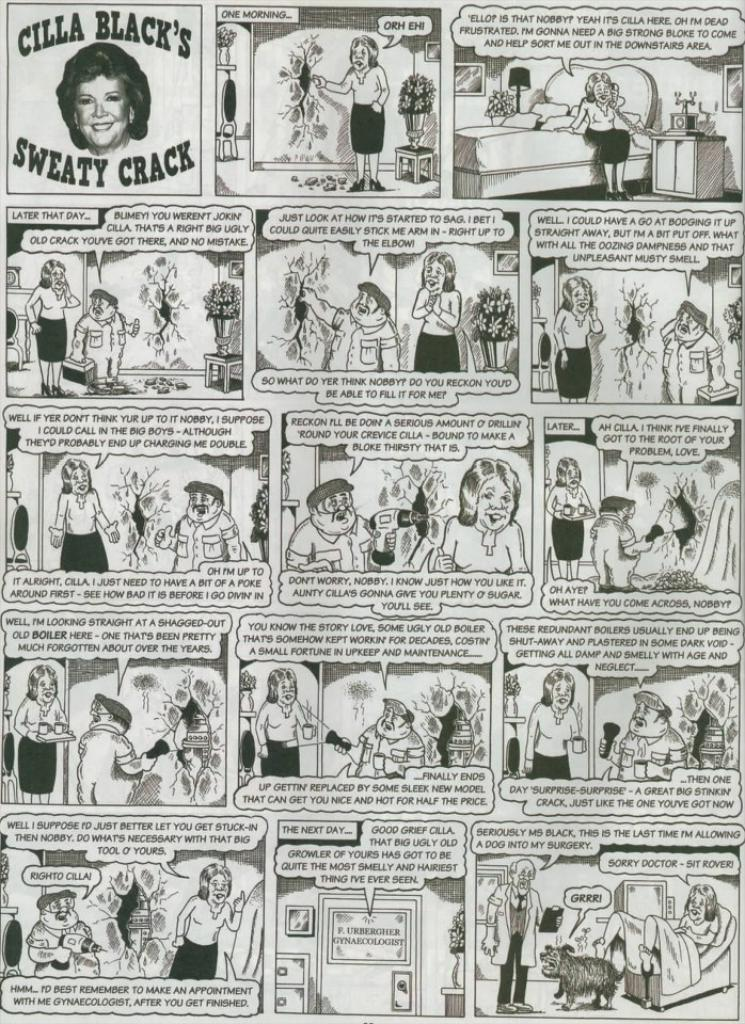What is depicted on the paper in the image? There is a paper with comic characters in the image. Can you describe the writing on the paper with comic characters? Yes, there is writing on the paper with comic characters. Where is the person's face located in the image? The person's face is in the top left corner of the image. What is written on the person's face in the image? There is writing on the person's face in the image. How many beds can be seen in the image? There are no beds present in the image. What type of boundary is depicted in the image? There is no boundary depicted in the image. 